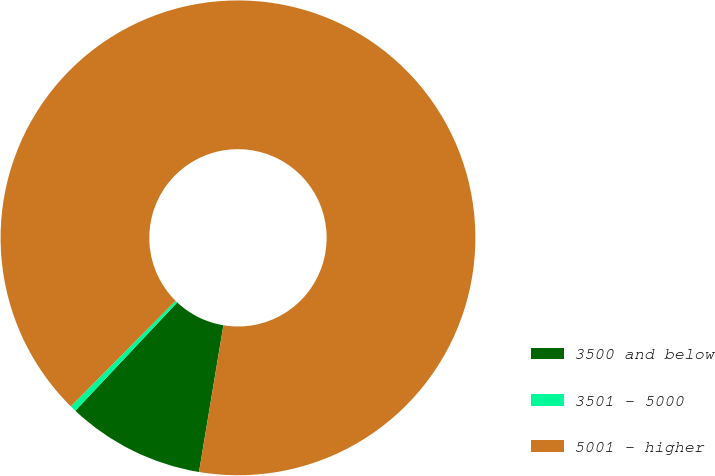<chart> <loc_0><loc_0><loc_500><loc_500><pie_chart><fcel>3500 and below<fcel>3501 - 5000<fcel>5001 - higher<nl><fcel>9.39%<fcel>0.42%<fcel>90.19%<nl></chart> 